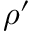Convert formula to latex. <formula><loc_0><loc_0><loc_500><loc_500>\rho ^ { \prime }</formula> 